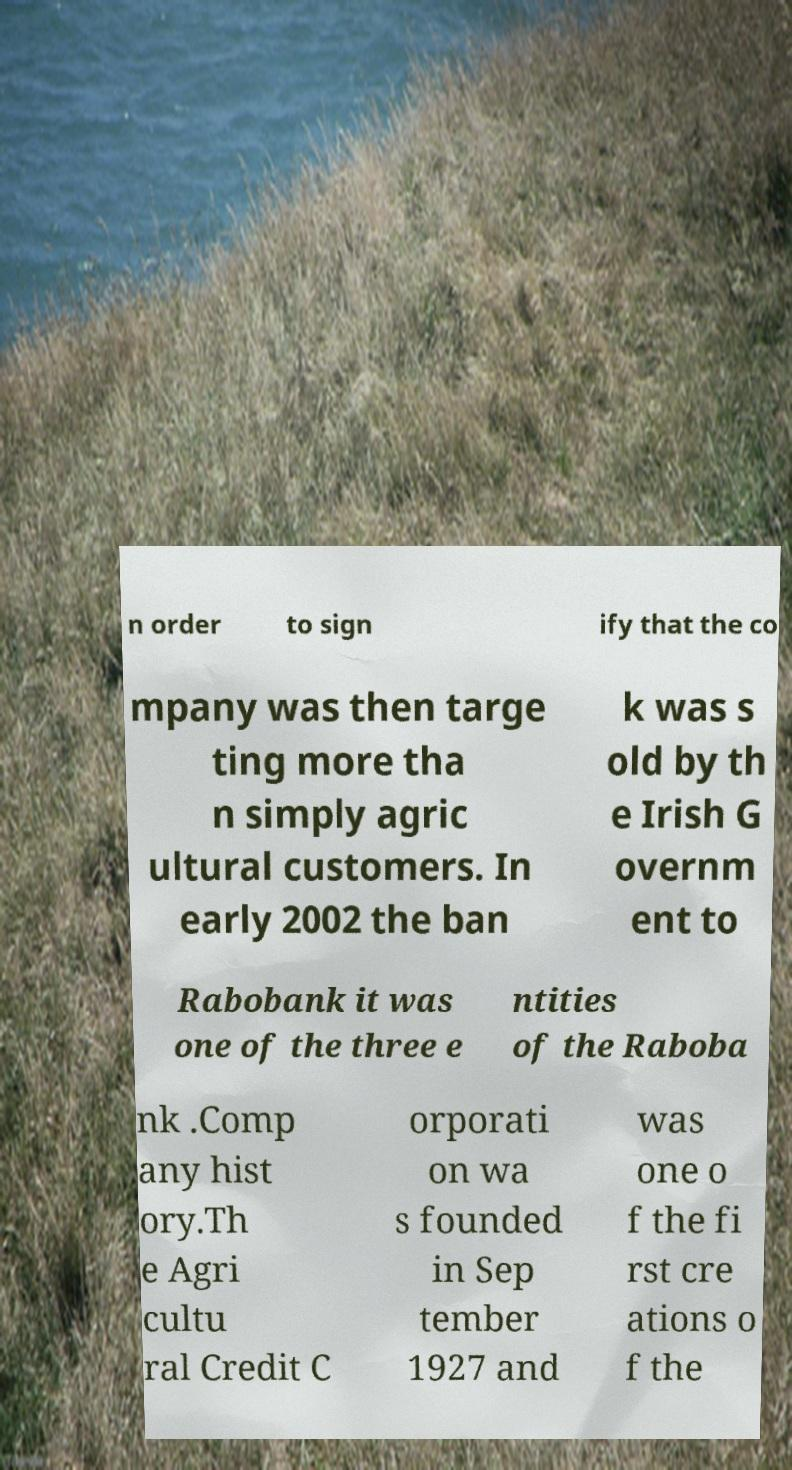For documentation purposes, I need the text within this image transcribed. Could you provide that? n order to sign ify that the co mpany was then targe ting more tha n simply agric ultural customers. In early 2002 the ban k was s old by th e Irish G overnm ent to Rabobank it was one of the three e ntities of the Raboba nk .Comp any hist ory.Th e Agri cultu ral Credit C orporati on wa s founded in Sep tember 1927 and was one o f the fi rst cre ations o f the 